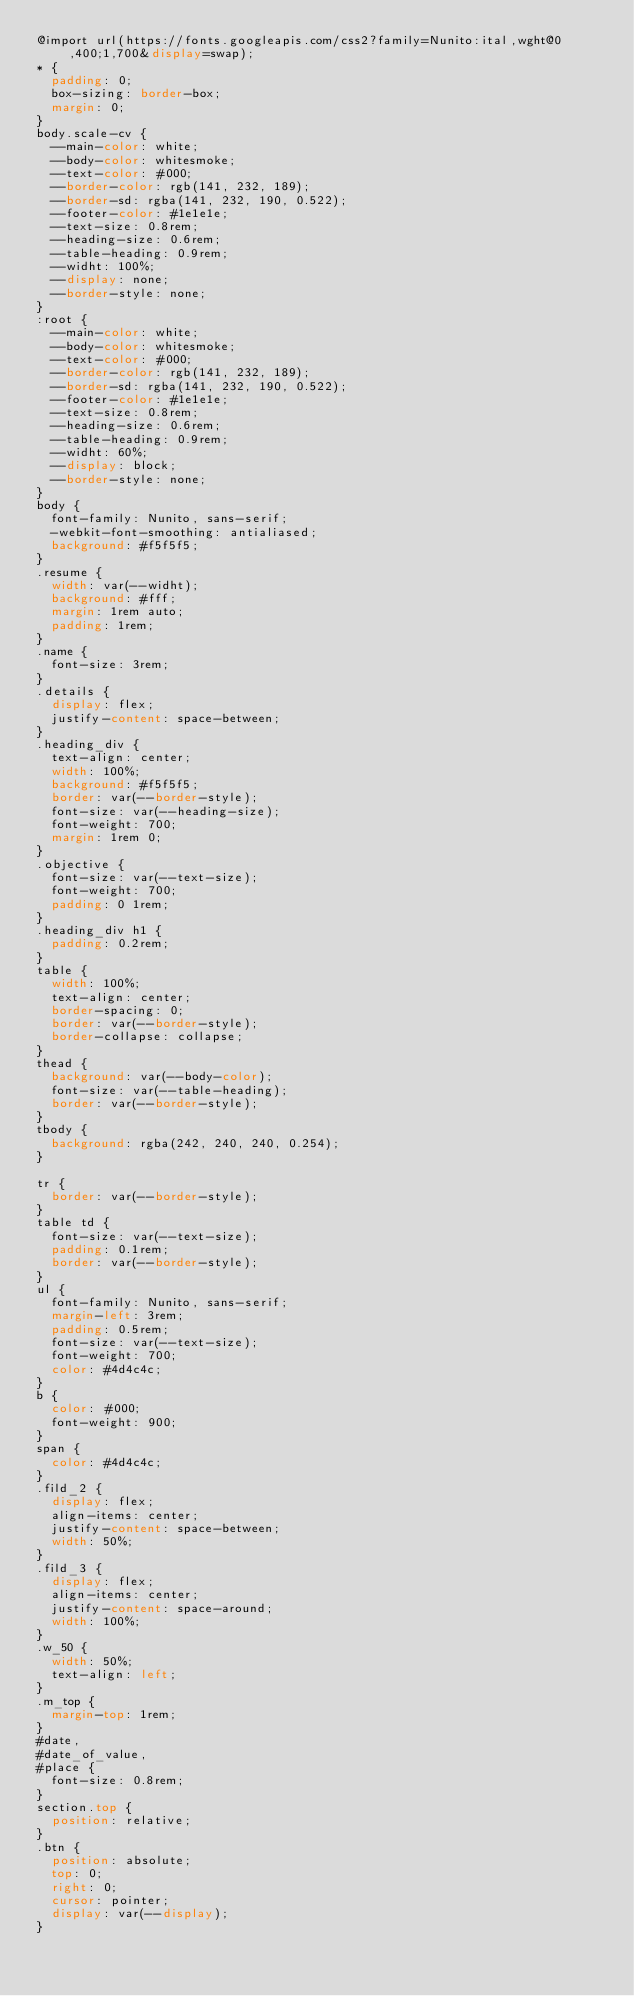Convert code to text. <code><loc_0><loc_0><loc_500><loc_500><_CSS_>@import url(https://fonts.googleapis.com/css2?family=Nunito:ital,wght@0,400;1,700&display=swap);
* {
  padding: 0;
  box-sizing: border-box;
  margin: 0;
}
body.scale-cv {
  --main-color: white;
  --body-color: whitesmoke;
  --text-color: #000;
  --border-color: rgb(141, 232, 189);
  --border-sd: rgba(141, 232, 190, 0.522);
  --footer-color: #1e1e1e;
  --text-size: 0.8rem;
  --heading-size: 0.6rem;
  --table-heading: 0.9rem;
  --widht: 100%;
  --display: none;
  --border-style: none;
}
:root {
  --main-color: white;
  --body-color: whitesmoke;
  --text-color: #000;
  --border-color: rgb(141, 232, 189);
  --border-sd: rgba(141, 232, 190, 0.522);
  --footer-color: #1e1e1e;
  --text-size: 0.8rem;
  --heading-size: 0.6rem;
  --table-heading: 0.9rem;
  --widht: 60%;
  --display: block;
  --border-style: none;
}
body {
  font-family: Nunito, sans-serif;
  -webkit-font-smoothing: antialiased;
  background: #f5f5f5;
}
.resume {
  width: var(--widht);
  background: #fff;
  margin: 1rem auto;
  padding: 1rem;
}
.name {
  font-size: 3rem;
}
.details {
  display: flex;
  justify-content: space-between;
}
.heading_div {
  text-align: center;
  width: 100%;
  background: #f5f5f5;
  border: var(--border-style);
  font-size: var(--heading-size);
  font-weight: 700;
  margin: 1rem 0;
}
.objective {
  font-size: var(--text-size);
  font-weight: 700;
  padding: 0 1rem;
}
.heading_div h1 {
  padding: 0.2rem;
}
table {
  width: 100%;
  text-align: center;
  border-spacing: 0;
  border: var(--border-style);
  border-collapse: collapse;
}
thead {
  background: var(--body-color);
  font-size: var(--table-heading);
  border: var(--border-style);
}
tbody {
  background: rgba(242, 240, 240, 0.254);
}

tr {
  border: var(--border-style);
}
table td {
  font-size: var(--text-size);
  padding: 0.1rem;
  border: var(--border-style);
}
ul {
  font-family: Nunito, sans-serif;
  margin-left: 3rem;
  padding: 0.5rem;
  font-size: var(--text-size);
  font-weight: 700;
  color: #4d4c4c;
}
b {
  color: #000;
  font-weight: 900;
}
span {
  color: #4d4c4c;
}
.fild_2 {
  display: flex;
  align-items: center;
  justify-content: space-between;
  width: 50%;
}
.fild_3 {
  display: flex;
  align-items: center;
  justify-content: space-around;
  width: 100%;
}
.w_50 {
  width: 50%;
  text-align: left;
}
.m_top {
  margin-top: 1rem;
}
#date,
#date_of_value,
#place {
  font-size: 0.8rem;
}
section.top {
  position: relative;
}
.btn {
  position: absolute;
  top: 0;
  right: 0;
  cursor: pointer;
  display: var(--display);
}
</code> 